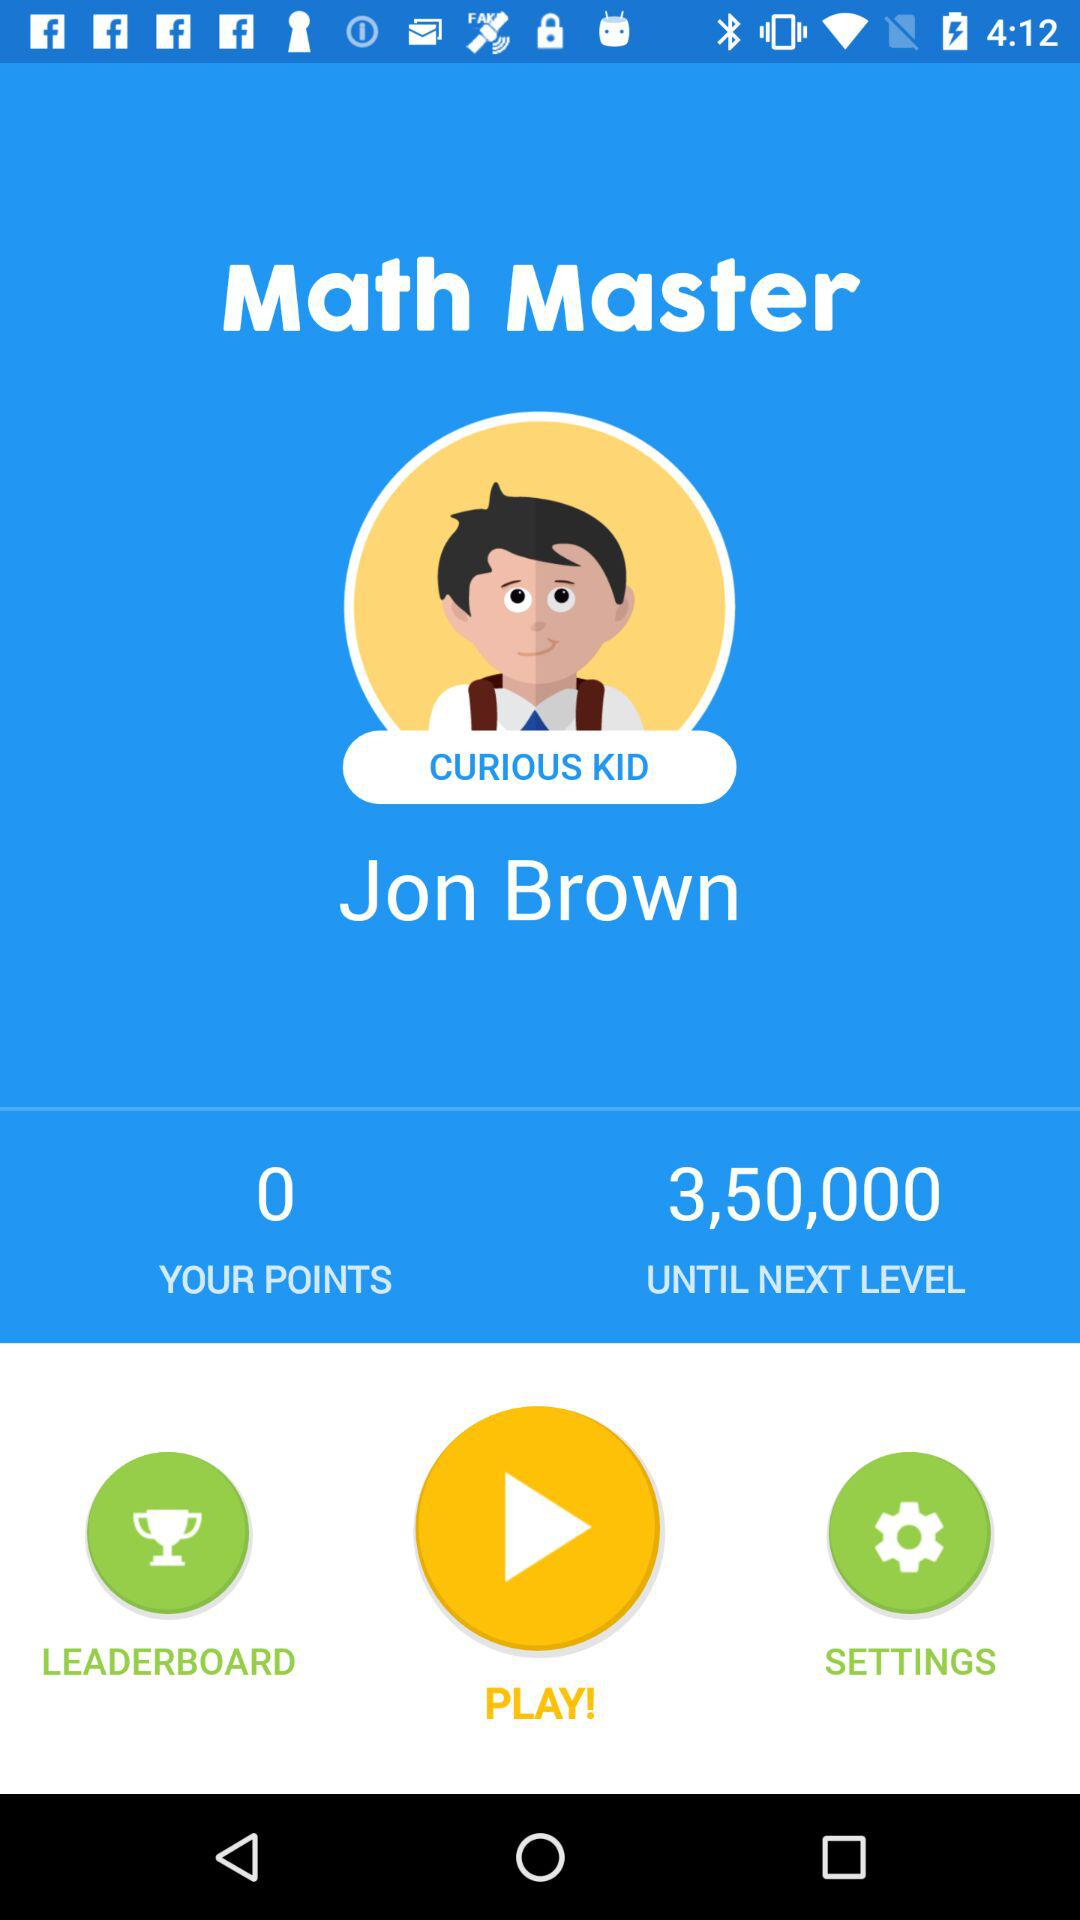What is the name of the player?
Answer the question using a single word or phrase. Jon Brown 